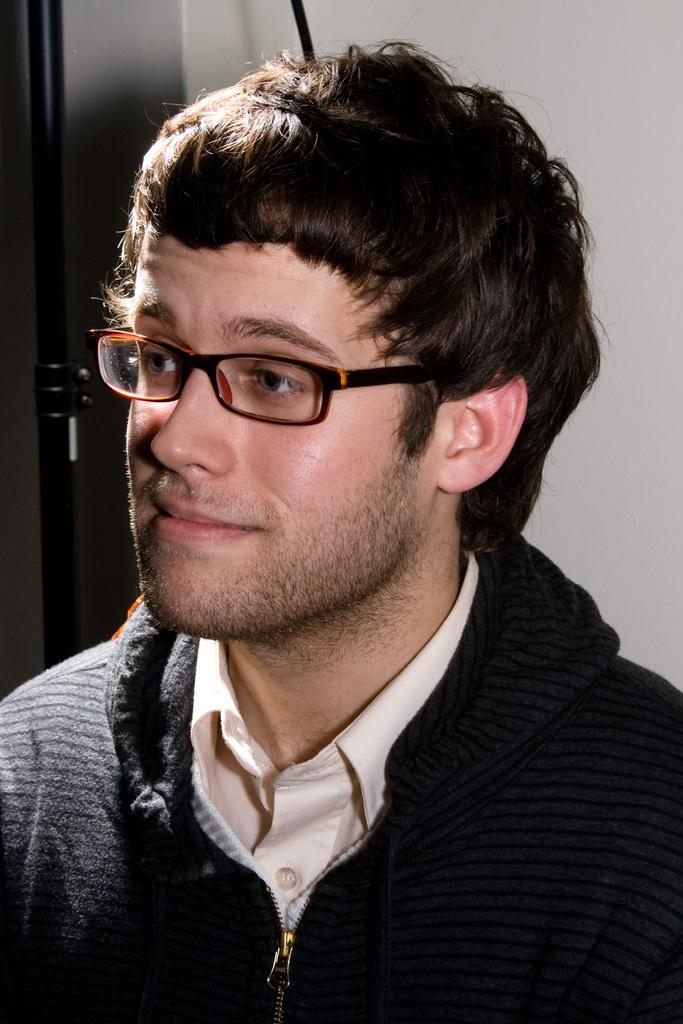What is the main subject of the image? The main subject of the image is a man. What is the man wearing in the image? The man is wearing a black jacket. What accessory can be seen on the man's face? The man has spectacles. What can be seen in the background of the image? There is a wall in the background of the image. What type of orange is being held by the man in the image? There is no orange present in the image; the man is not holding any fruit. What color is the rose on the ground in the image? There is no rose present in the image; the ground is not visible in the image. 